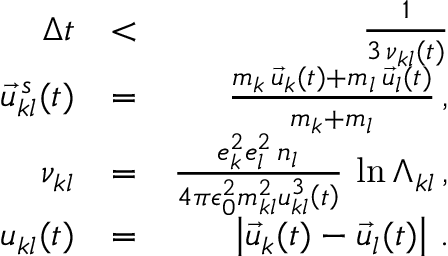<formula> <loc_0><loc_0><loc_500><loc_500>\begin{array} { r l r } { \Delta t } & { < } & { \frac { 1 } { 3 \, \nu _ { k l } ( t ) } } \\ { \vec { u } _ { k l } ^ { \, s } ( t ) } & { = } & { \frac { m _ { k } \, \vec { u } _ { k } ( t ) + m _ { l } \, \vec { u } _ { l } ( t ) } { m _ { k } + m _ { l } } \, , } \\ { \nu _ { k l } } & { = } & { \frac { e _ { k } ^ { 2 } e _ { l } ^ { 2 } \, n _ { l } } { 4 \pi \epsilon _ { 0 } ^ { 2 } m _ { k l } ^ { 2 } u _ { k l } ^ { 3 } \left ( t \right ) } \, \ln \Lambda _ { k l } \, , } \\ { u _ { k l } ( t ) } & { = } & { \left | \vec { u } _ { k } ( t ) - \vec { u } _ { l } ( t ) \right | \, . } \end{array}</formula> 